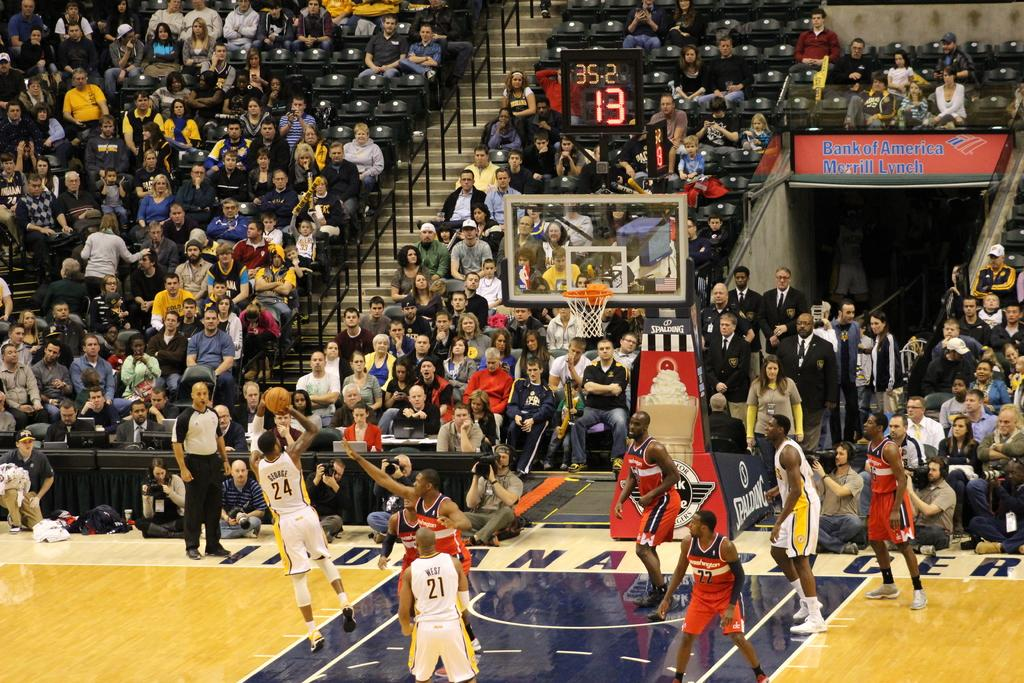<image>
Render a clear and concise summary of the photo. A sign for Bank of America hangs above the entrance to a basketball court. 